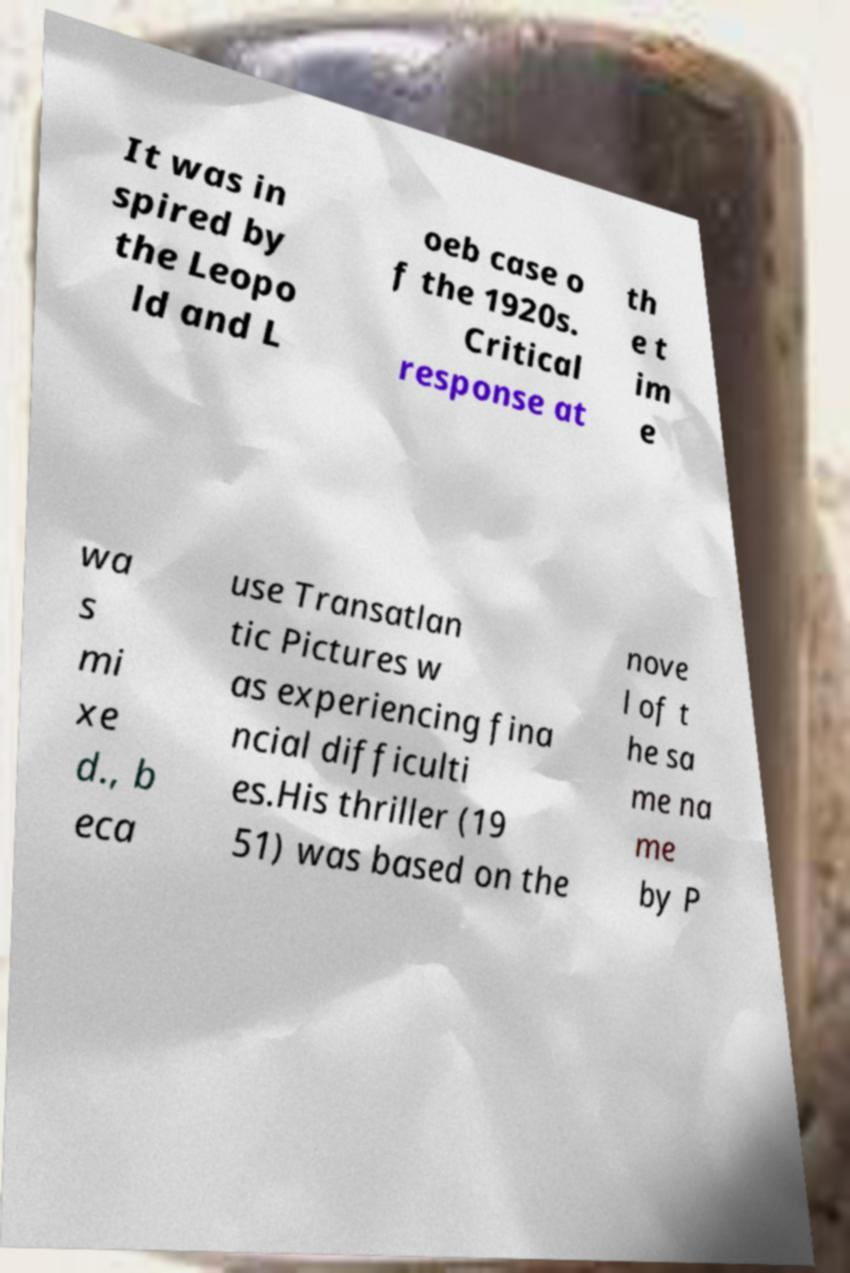Could you extract and type out the text from this image? It was in spired by the Leopo ld and L oeb case o f the 1920s. Critical response at th e t im e wa s mi xe d., b eca use Transatlan tic Pictures w as experiencing fina ncial difficulti es.His thriller (19 51) was based on the nove l of t he sa me na me by P 